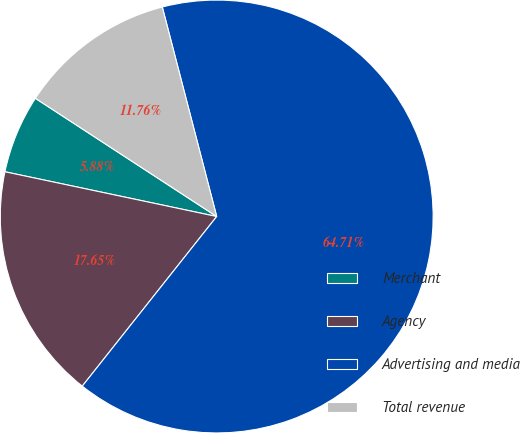<chart> <loc_0><loc_0><loc_500><loc_500><pie_chart><fcel>Merchant<fcel>Agency<fcel>Advertising and media<fcel>Total revenue<nl><fcel>5.88%<fcel>17.65%<fcel>64.71%<fcel>11.76%<nl></chart> 